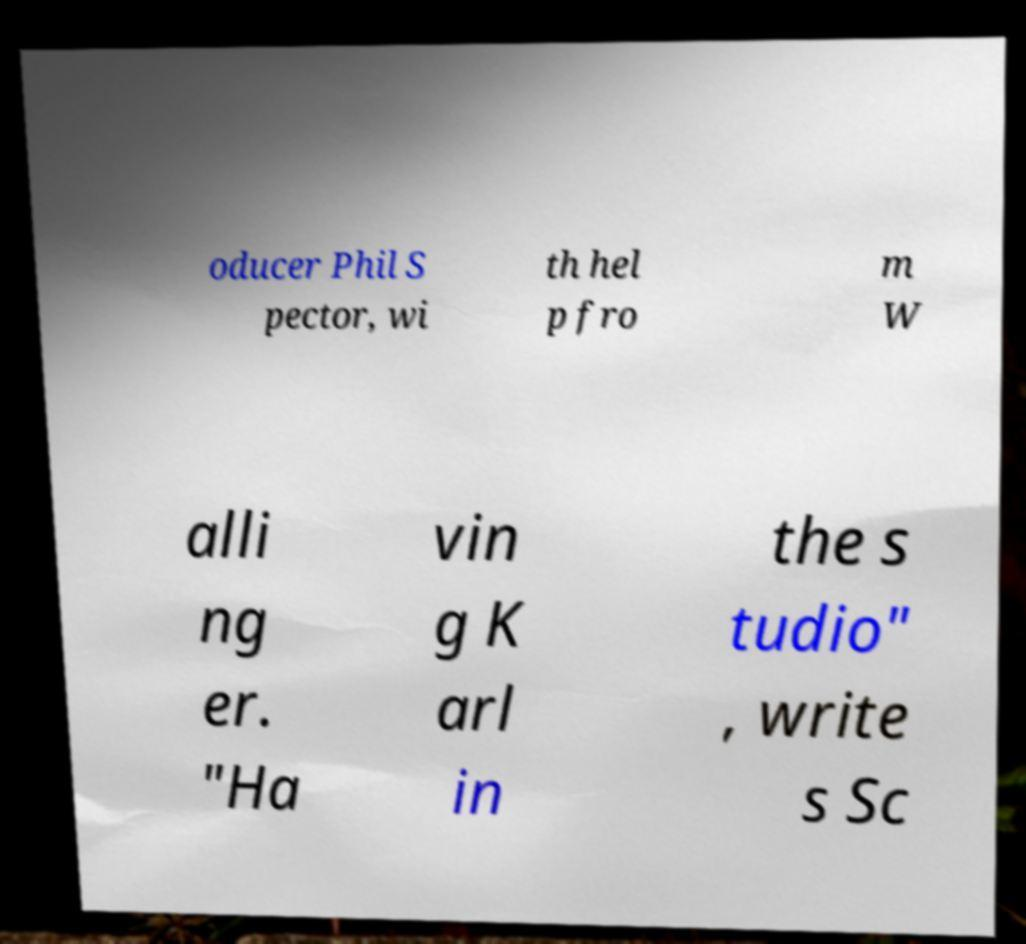I need the written content from this picture converted into text. Can you do that? oducer Phil S pector, wi th hel p fro m W alli ng er. "Ha vin g K arl in the s tudio" , write s Sc 